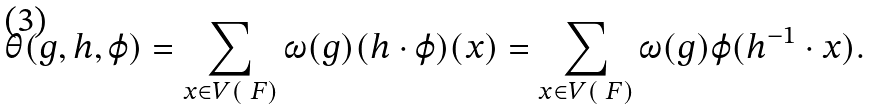<formula> <loc_0><loc_0><loc_500><loc_500>\theta ( g , h , \varphi ) = \sum _ { x \in V ( \ F ) } \omega ( g ) ( h \cdot \varphi ) ( x ) = \sum _ { x \in V ( \ F ) } \omega ( g ) \varphi ( h ^ { - 1 } \cdot x ) .</formula> 